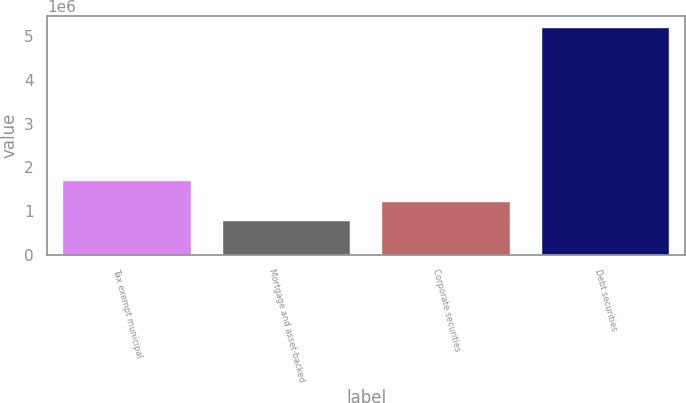<chart> <loc_0><loc_0><loc_500><loc_500><bar_chart><fcel>Tax exempt municipal<fcel>Mortgage and asset-backed<fcel>Corporate securities<fcel>Debt securities<nl><fcel>1.68946e+06<fcel>766202<fcel>1.2096e+06<fcel>5.20014e+06<nl></chart> 